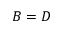<formula> <loc_0><loc_0><loc_500><loc_500>B = D</formula> 